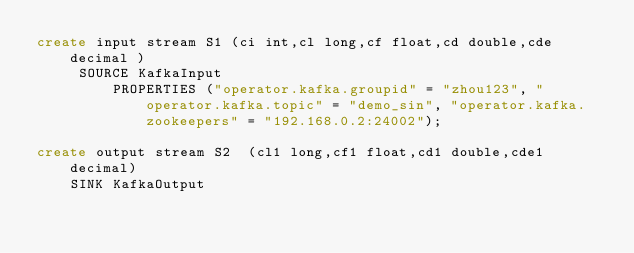<code> <loc_0><loc_0><loc_500><loc_500><_SQL_>create input stream S1 (ci int,cl long,cf float,cd double,cde decimal )
     SOURCE KafkaInput
         PROPERTIES ("operator.kafka.groupid" = "zhou123", "operator.kafka.topic" = "demo_sin", "operator.kafka.zookeepers" = "192.168.0.2:24002");
                 
create output stream S2  (cl1 long,cf1 float,cd1 double,cde1 decimal)
    SINK KafkaOutput</code> 